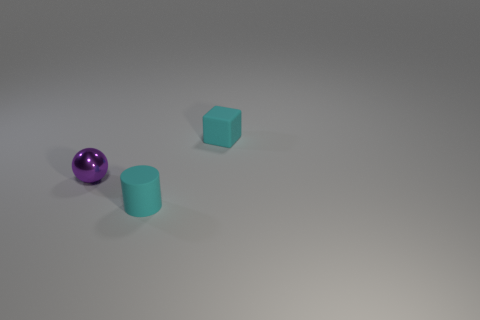Add 1 balls. How many objects exist? 4 Subtract all cylinders. How many objects are left? 2 Subtract all brown cubes. How many blue cylinders are left? 0 Subtract all big gray matte blocks. Subtract all cubes. How many objects are left? 2 Add 3 small cyan matte objects. How many small cyan matte objects are left? 5 Add 1 cyan things. How many cyan things exist? 3 Subtract 0 purple cylinders. How many objects are left? 3 Subtract all gray cubes. Subtract all blue cylinders. How many cubes are left? 1 